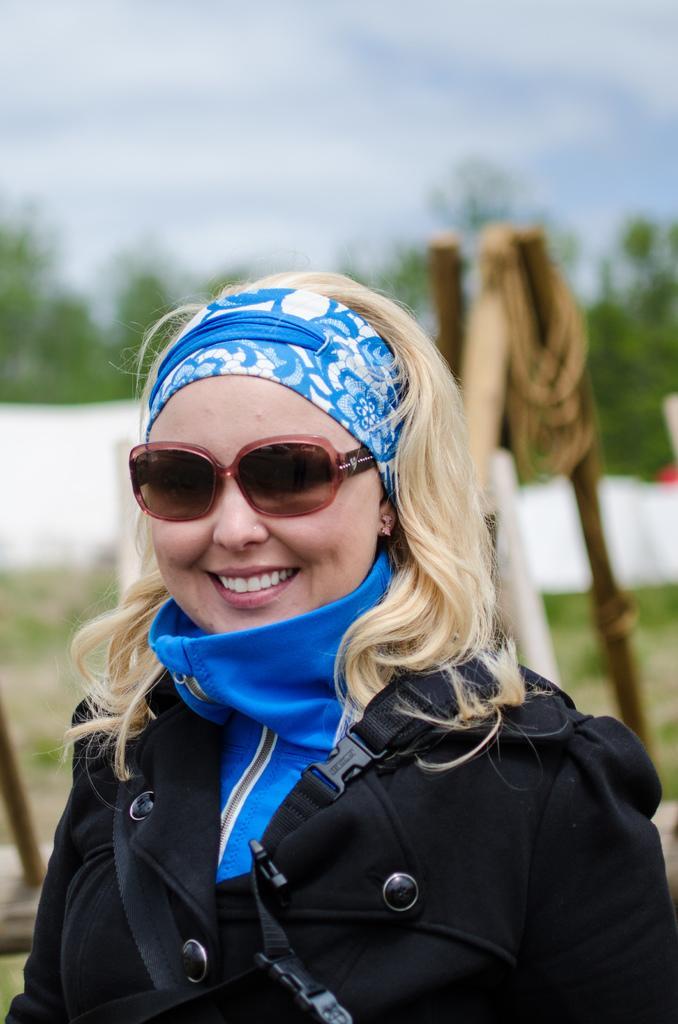How would you summarize this image in a sentence or two? In this image there is a lady standing wearing a coat, glasses, in the background it is blurred. 